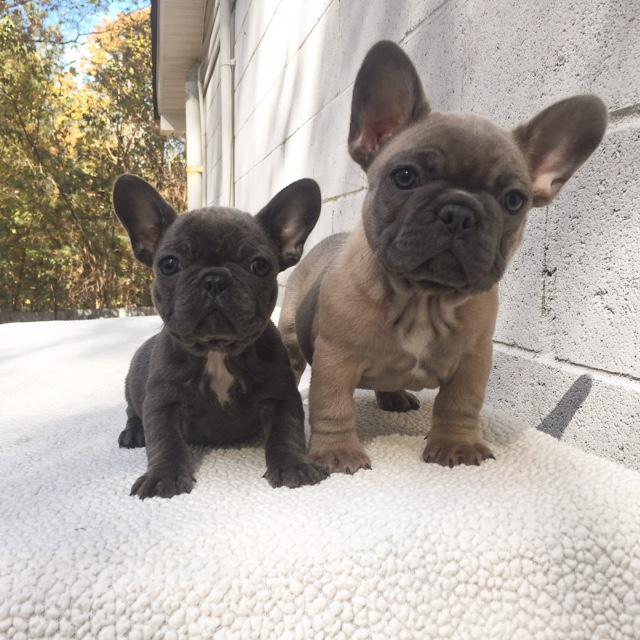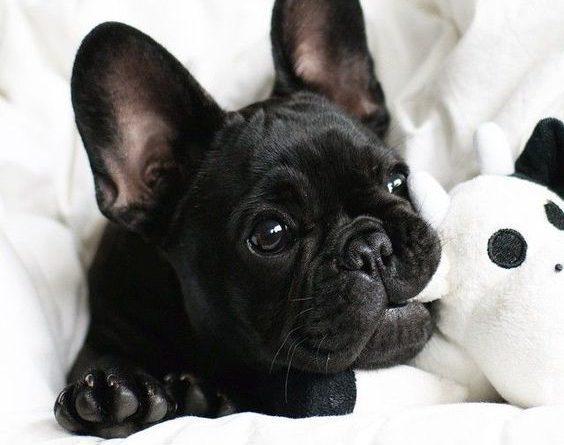The first image is the image on the left, the second image is the image on the right. For the images shown, is this caption "There are exactly three dogs." true? Answer yes or no. Yes. The first image is the image on the left, the second image is the image on the right. Analyze the images presented: Is the assertion "One image shows exactly two real puppies posed on a plush surface." valid? Answer yes or no. Yes. 